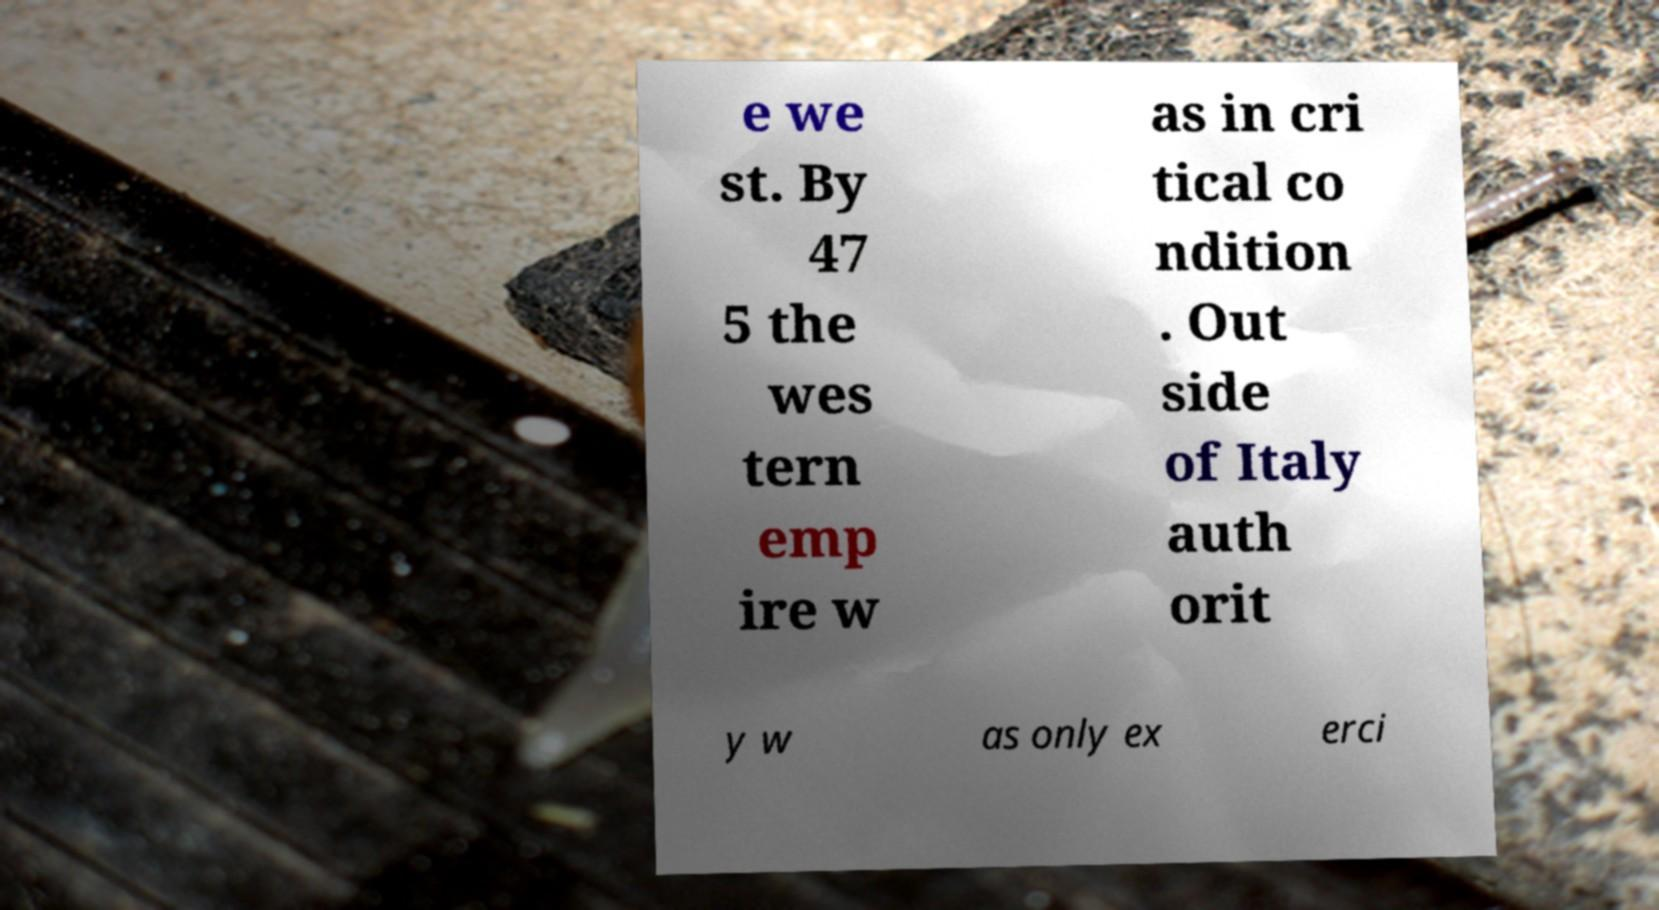Could you extract and type out the text from this image? e we st. By 47 5 the wes tern emp ire w as in cri tical co ndition . Out side of Italy auth orit y w as only ex erci 